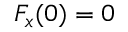<formula> <loc_0><loc_0><loc_500><loc_500>F _ { x } ( 0 ) = 0</formula> 